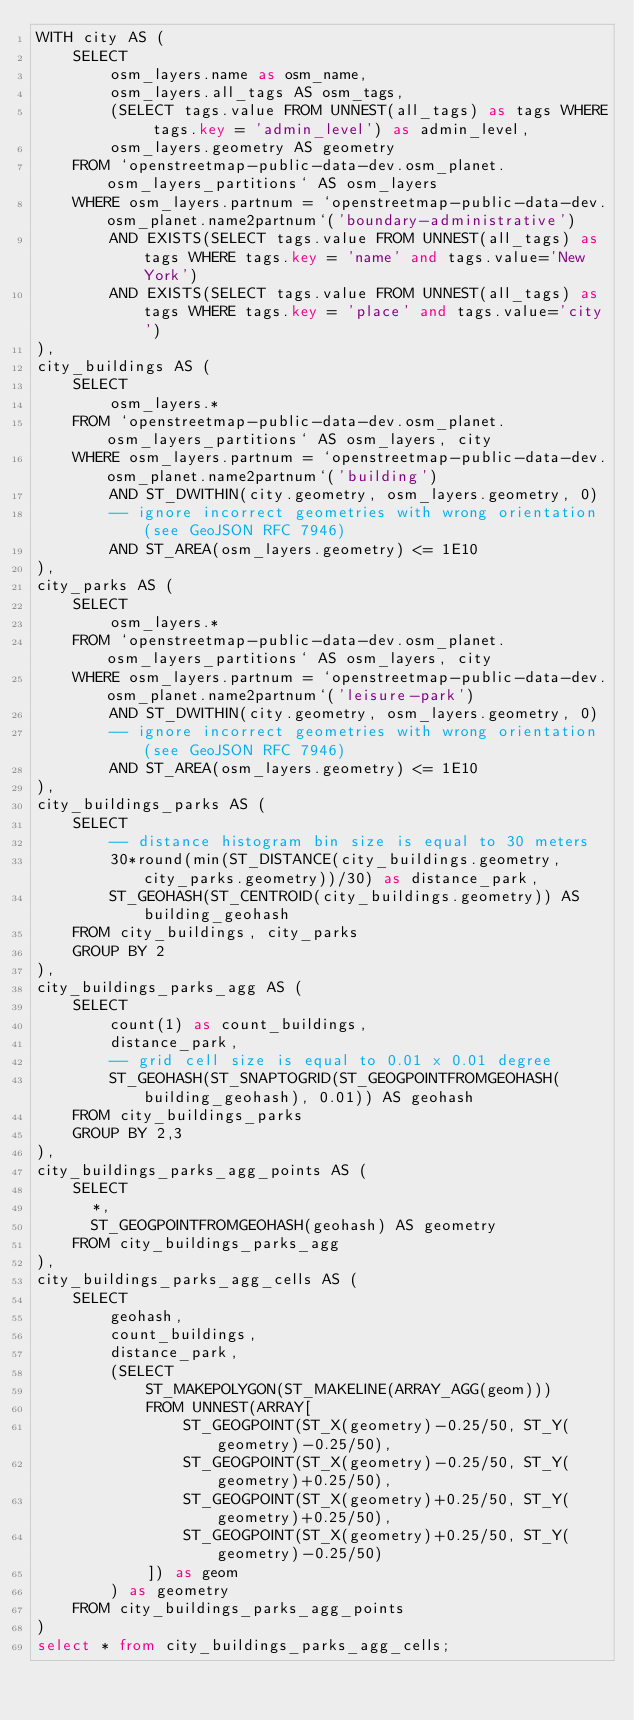Convert code to text. <code><loc_0><loc_0><loc_500><loc_500><_SQL_>WITH city AS (
	SELECT
		osm_layers.name as osm_name,
		osm_layers.all_tags AS osm_tags,
		(SELECT tags.value FROM UNNEST(all_tags) as tags WHERE tags.key = 'admin_level') as admin_level,
		osm_layers.geometry AS geometry
	FROM `openstreetmap-public-data-dev.osm_planet.osm_layers_partitions` AS osm_layers
	WHERE osm_layers.partnum = `openstreetmap-public-data-dev.osm_planet.name2partnum`('boundary-administrative')
		AND EXISTS(SELECT tags.value FROM UNNEST(all_tags) as tags WHERE tags.key = 'name' and tags.value='New York')
		AND EXISTS(SELECT tags.value FROM UNNEST(all_tags) as tags WHERE tags.key = 'place' and tags.value='city')
),
city_buildings AS (
	SELECT
		osm_layers.*
	FROM `openstreetmap-public-data-dev.osm_planet.osm_layers_partitions` AS osm_layers, city
	WHERE osm_layers.partnum = `openstreetmap-public-data-dev.osm_planet.name2partnum`('building')
		AND ST_DWITHIN(city.geometry, osm_layers.geometry, 0)
		-- ignore incorrect geometries with wrong orientation (see GeoJSON RFC 7946)
		AND ST_AREA(osm_layers.geometry) <= 1E10
),
city_parks AS (
	SELECT
		osm_layers.*
	FROM `openstreetmap-public-data-dev.osm_planet.osm_layers_partitions` AS osm_layers, city
	WHERE osm_layers.partnum = `openstreetmap-public-data-dev.osm_planet.name2partnum`('leisure-park')
		AND ST_DWITHIN(city.geometry, osm_layers.geometry, 0)
		-- ignore incorrect geometries with wrong orientation (see GeoJSON RFC 7946)
		AND ST_AREA(osm_layers.geometry) <= 1E10
),
city_buildings_parks AS (
	SELECT
		-- distance histogram bin size is equal to 30 meters
		30*round(min(ST_DISTANCE(city_buildings.geometry, city_parks.geometry))/30) as distance_park,
		ST_GEOHASH(ST_CENTROID(city_buildings.geometry)) AS building_geohash
	FROM city_buildings, city_parks
	GROUP BY 2
),
city_buildings_parks_agg AS (
	SELECT
		count(1) as count_buildings,
		distance_park,
		-- grid cell size is equal to 0.01 x 0.01 degree
		ST_GEOHASH(ST_SNAPTOGRID(ST_GEOGPOINTFROMGEOHASH(building_geohash), 0.01)) AS geohash
	FROM city_buildings_parks
	GROUP BY 2,3
),
city_buildings_parks_agg_points AS (
	SELECT
	  *,
	  ST_GEOGPOINTFROMGEOHASH(geohash) AS geometry
	FROM city_buildings_parks_agg
),
city_buildings_parks_agg_cells AS (
	SELECT
		geohash,
		count_buildings,
		distance_park,
		(SELECT
			ST_MAKEPOLYGON(ST_MAKELINE(ARRAY_AGG(geom)))
			FROM UNNEST(ARRAY[
				ST_GEOGPOINT(ST_X(geometry)-0.25/50, ST_Y(geometry)-0.25/50),
				ST_GEOGPOINT(ST_X(geometry)-0.25/50, ST_Y(geometry)+0.25/50),
				ST_GEOGPOINT(ST_X(geometry)+0.25/50, ST_Y(geometry)+0.25/50),
				ST_GEOGPOINT(ST_X(geometry)+0.25/50, ST_Y(geometry)-0.25/50)
			]) as geom
		) as geometry
	FROM city_buildings_parks_agg_points
)
select * from city_buildings_parks_agg_cells;
</code> 